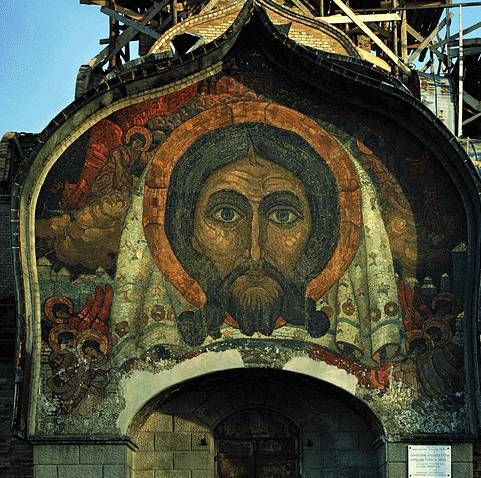What does the expression on Jesus Christ's face convey to viewers? The facial expression of Jesus Christ in the mosaic is solemn and serene, conveying a sense of benevolence and divine composure. This depiction is intended to inspire reverence and contemplation among viewers, evoking a spiritual connection and reflection on Christian themes. The eyes, often the focal point in Byzantine religious portraiture, are depicted with a penetrating gaze that seems to transcend the physical space, inviting those who view it to consider deeper spiritual truths and the embodiment of divine wisdom. 